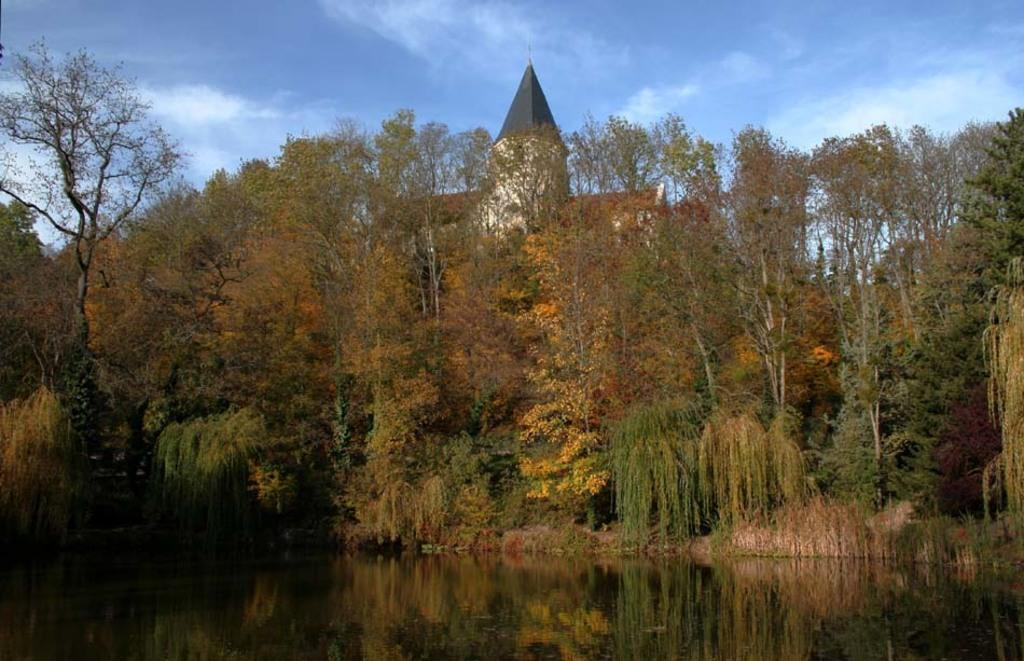What type of vegetation can be seen in the image? There are trees in the image. What is located at the bottom of the image? There is water at the bottom of the image. What type of structure is visible in the image? There is a building visible in the image. What is visible in the background of the image? The sky is visible in the background of the image. What color is the ink used to write on the trees in the image? There is no ink or writing present on the trees in the image. Can you hear the trees laughing in the image? Trees do not have the ability to laugh, and there is no sound present in the image. 